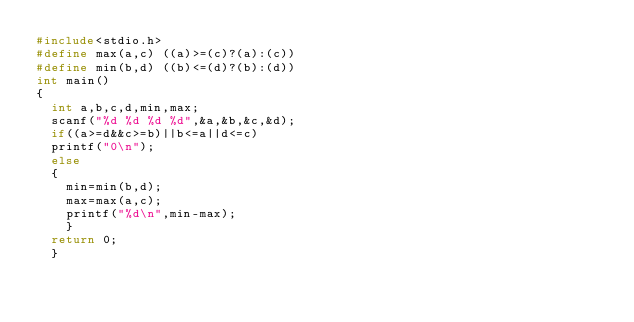<code> <loc_0><loc_0><loc_500><loc_500><_C_>#include<stdio.h>
#define max(a,c) ((a)>=(c)?(a):(c))
#define min(b,d) ((b)<=(d)?(b):(d))
int main()
{
	int a,b,c,d,min,max;
	scanf("%d %d %d %d",&a,&b,&c,&d);
	if((a>=d&&c>=b)||b<=a||d<=c)
	printf("0\n");
	else
	{
		min=min(b,d);
		max=max(a,c);
		printf("%d\n",min-max);
		}
	return 0;
	}</code> 